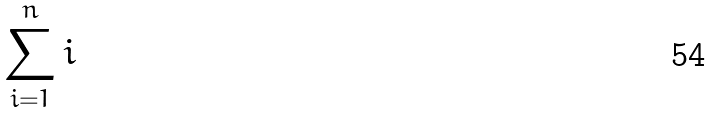Convert formula to latex. <formula><loc_0><loc_0><loc_500><loc_500>\sum _ { i = 1 } ^ { n } i</formula> 